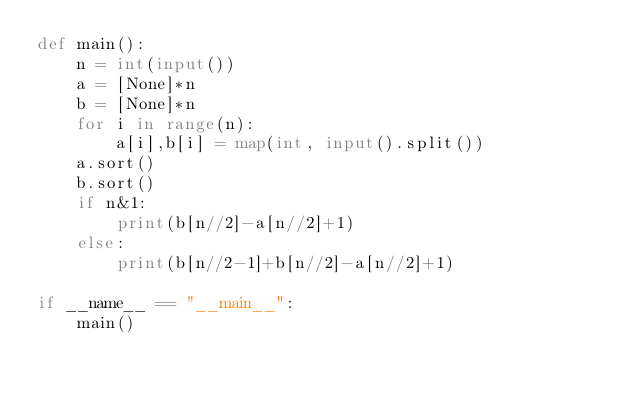<code> <loc_0><loc_0><loc_500><loc_500><_Python_>def main():
    n = int(input())
    a = [None]*n
    b = [None]*n
    for i in range(n):
        a[i],b[i] = map(int, input().split())
    a.sort()
    b.sort()    
    if n&1:
        print(b[n//2]-a[n//2]+1)
    else:
        print(b[n//2-1]+b[n//2]-a[n//2]+1)
            
if __name__ == "__main__":
    main()</code> 